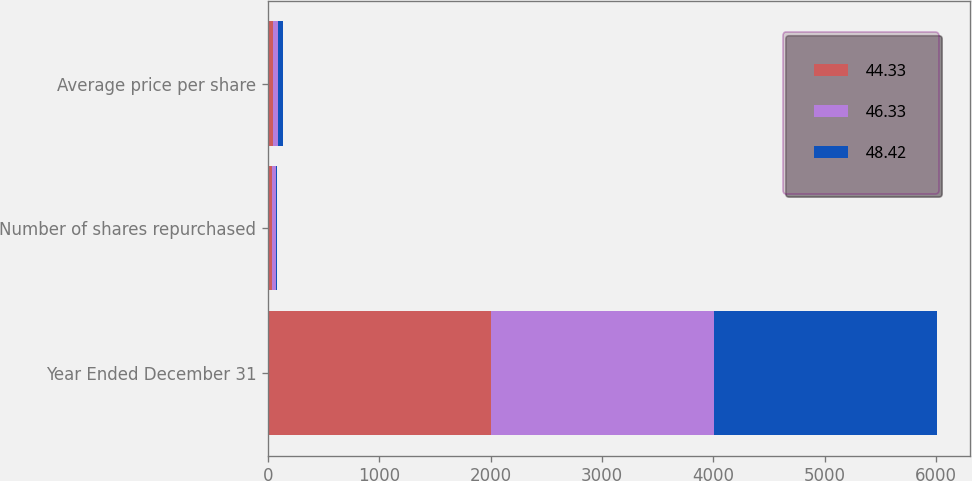Convert chart. <chart><loc_0><loc_0><loc_500><loc_500><stacked_bar_chart><ecel><fcel>Year Ended December 31<fcel>Number of shares repurchased<fcel>Average price per share<nl><fcel>44.33<fcel>2004<fcel>38<fcel>46.33<nl><fcel>46.33<fcel>2003<fcel>33<fcel>44.33<nl><fcel>48.42<fcel>2002<fcel>14<fcel>48.42<nl></chart> 